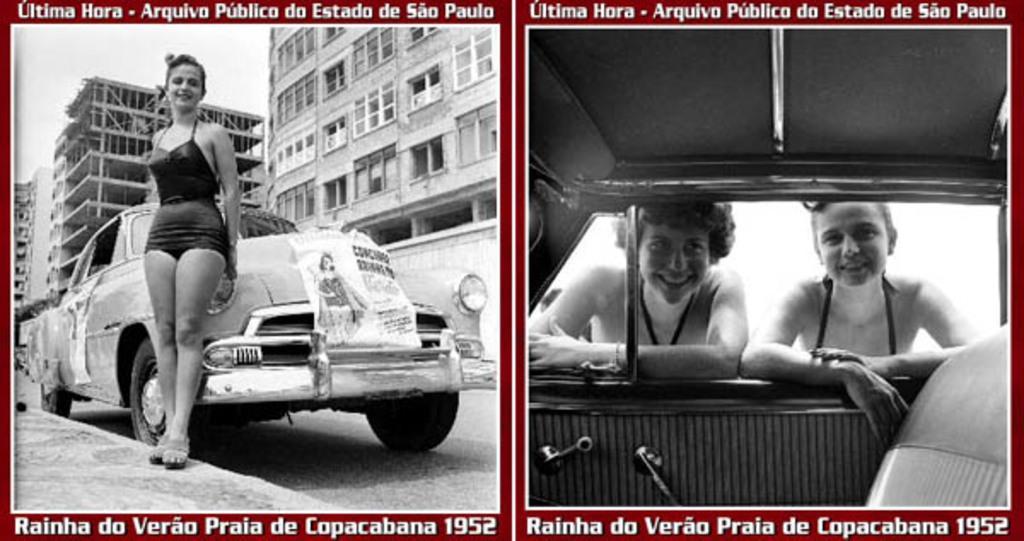Can you describe this image briefly? In this image I can see a collage of 2 images. In the left image a woman is standing in front of a car and there are buildings at the back. In the right image 2 people are standing outside the car and resting through its window. 